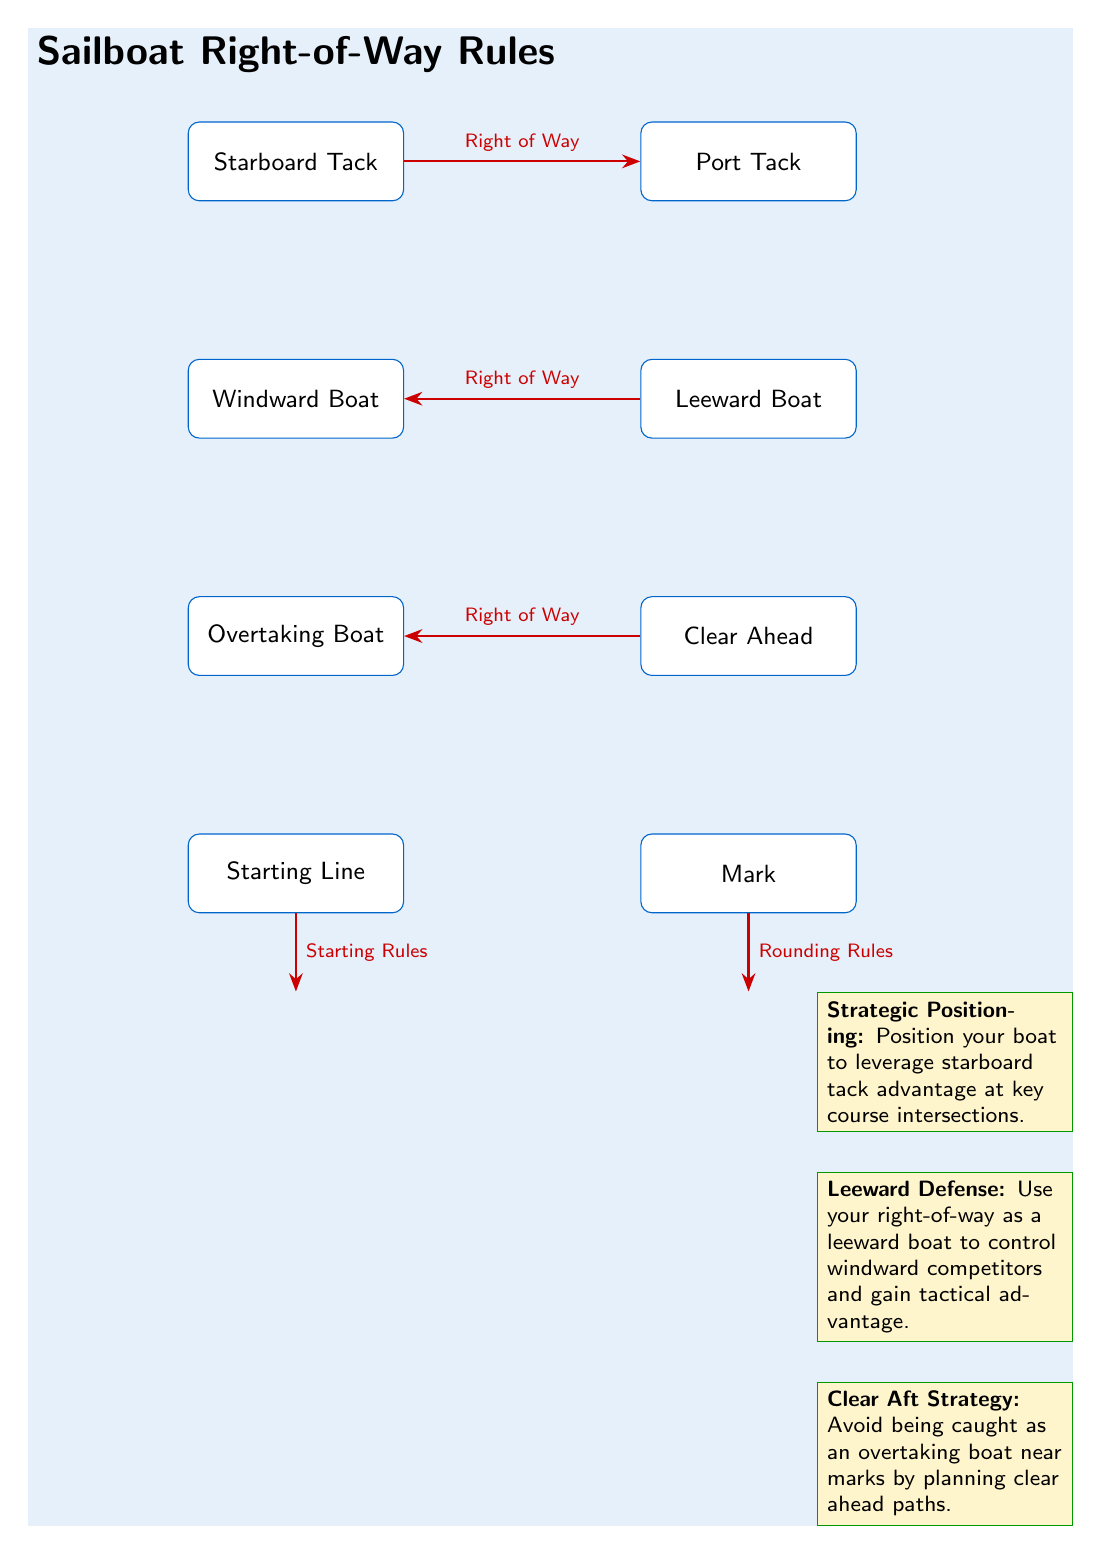What is the right-of-way relationship between the starboard tack and port tack? The diagram indicates that the starboard tack has the right of way over the port tack, as represented by the arrow labeled 'Right of Way' pointing from starboard to port.
Answer: Right of Way Which boat type is positioned windward relative to the leeward boat? The windward boat is above the leeward boat in the diagram, showing its position relative to the leeward boat.
Answer: Windward Boat How many strategic notes are represented in the diagram? The diagram contains three strategic positioning notes, as identified in the bottom section of the diagram.
Answer: 3 What does the rule indicate about overtaking boats in relation to the clear ahead condition? The diagram states that an overtaking boat has the right of way if it is clear ahead, which is depicted by the arrow labeled 'Right of Way' between the clear ahead and overtaking boat nodes.
Answer: Right of Way What is the strategic implication of your position as a leeward boat? The leeward defense note suggests that a leeward boat can use its right of way to control windward competitors, gaining a tactical advantage.
Answer: Control windward competitors Explain the significance of the starting line in relation to the starting rules. The diagram indicates that the starting line is associated with specific rules, shown by the arrow labeled 'Starting Rules', emphasizing that it has regulations governing how races should commence.
Answer: Starting Rules What is the relationship between the mark and rounding rules? The diagram illustrates that there are specific rounding rules that apply at the mark, indicated by the arrow labeled 'Rounding Rules' pointing towards the mark node.
Answer: Rounding Rules Which tactical advantage can be obtained by positioning on starboard tack at key intersections? The note on strategic positioning emphasizes leveraging the starboard tack advantage as a method to dominate crucial course points during a race.
Answer: Leverage starboard tack advantage What is the tactical behavior suggested for avoiding complications as an overtaking boat? The clear aft strategy recommends planning paths that ensure clear ahead positioning to avoid issues near marks, illustrated in the corresponding note.
Answer: Clear ahead paths 